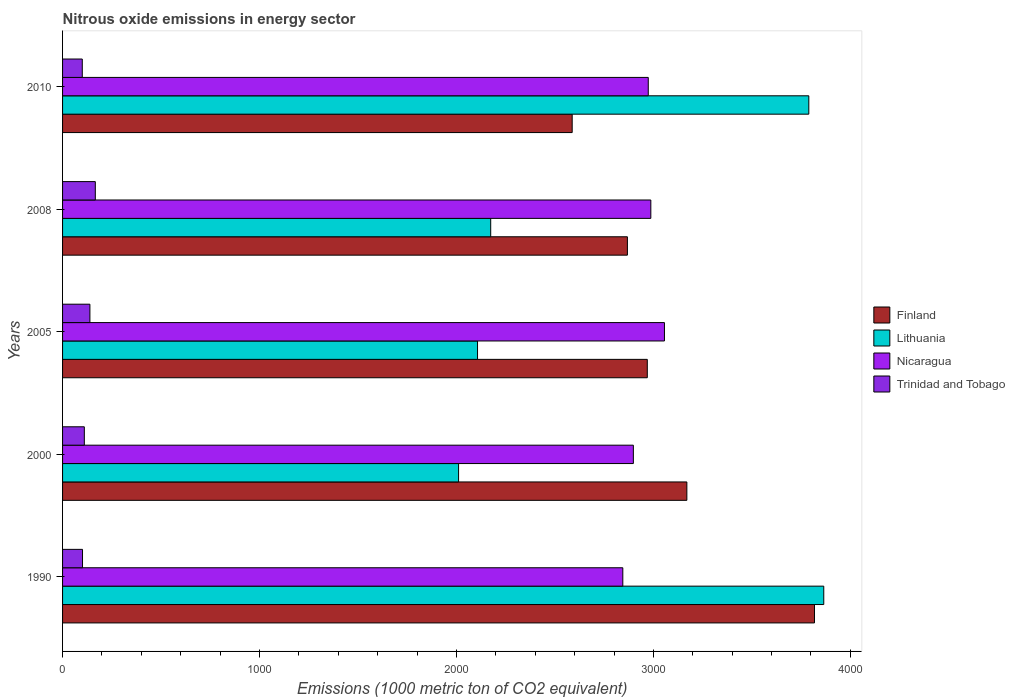Are the number of bars on each tick of the Y-axis equal?
Provide a short and direct response. Yes. How many bars are there on the 2nd tick from the top?
Ensure brevity in your answer.  4. What is the amount of nitrous oxide emitted in Lithuania in 2010?
Ensure brevity in your answer.  3789.1. Across all years, what is the maximum amount of nitrous oxide emitted in Lithuania?
Make the answer very short. 3865. Across all years, what is the minimum amount of nitrous oxide emitted in Lithuania?
Offer a terse response. 2010.8. In which year was the amount of nitrous oxide emitted in Nicaragua maximum?
Provide a short and direct response. 2005. What is the total amount of nitrous oxide emitted in Finland in the graph?
Give a very brief answer. 1.54e+04. What is the difference between the amount of nitrous oxide emitted in Lithuania in 2000 and that in 2005?
Provide a succinct answer. -96.2. What is the difference between the amount of nitrous oxide emitted in Trinidad and Tobago in 2010 and the amount of nitrous oxide emitted in Finland in 2008?
Make the answer very short. -2767.9. What is the average amount of nitrous oxide emitted in Finland per year?
Ensure brevity in your answer.  3082.48. In the year 2005, what is the difference between the amount of nitrous oxide emitted in Lithuania and amount of nitrous oxide emitted in Nicaragua?
Make the answer very short. -949.1. In how many years, is the amount of nitrous oxide emitted in Lithuania greater than 1200 1000 metric ton?
Ensure brevity in your answer.  5. What is the ratio of the amount of nitrous oxide emitted in Nicaragua in 2000 to that in 2005?
Offer a very short reply. 0.95. Is the amount of nitrous oxide emitted in Finland in 2000 less than that in 2010?
Give a very brief answer. No. Is the difference between the amount of nitrous oxide emitted in Lithuania in 1990 and 2010 greater than the difference between the amount of nitrous oxide emitted in Nicaragua in 1990 and 2010?
Your answer should be compact. Yes. What is the difference between the highest and the second highest amount of nitrous oxide emitted in Trinidad and Tobago?
Your answer should be very brief. 27.5. What is the difference between the highest and the lowest amount of nitrous oxide emitted in Lithuania?
Your answer should be compact. 1854.2. In how many years, is the amount of nitrous oxide emitted in Nicaragua greater than the average amount of nitrous oxide emitted in Nicaragua taken over all years?
Give a very brief answer. 3. What does the 2nd bar from the top in 2010 represents?
Offer a very short reply. Nicaragua. What does the 3rd bar from the bottom in 2005 represents?
Keep it short and to the point. Nicaragua. Is it the case that in every year, the sum of the amount of nitrous oxide emitted in Lithuania and amount of nitrous oxide emitted in Nicaragua is greater than the amount of nitrous oxide emitted in Finland?
Give a very brief answer. Yes. How many bars are there?
Ensure brevity in your answer.  20. How many years are there in the graph?
Keep it short and to the point. 5. Are the values on the major ticks of X-axis written in scientific E-notation?
Ensure brevity in your answer.  No. Does the graph contain any zero values?
Your answer should be very brief. No. Does the graph contain grids?
Your answer should be compact. No. How many legend labels are there?
Provide a succinct answer. 4. How are the legend labels stacked?
Ensure brevity in your answer.  Vertical. What is the title of the graph?
Ensure brevity in your answer.  Nitrous oxide emissions in energy sector. What is the label or title of the X-axis?
Provide a succinct answer. Emissions (1000 metric ton of CO2 equivalent). What is the Emissions (1000 metric ton of CO2 equivalent) of Finland in 1990?
Your answer should be very brief. 3817.9. What is the Emissions (1000 metric ton of CO2 equivalent) in Lithuania in 1990?
Offer a very short reply. 3865. What is the Emissions (1000 metric ton of CO2 equivalent) of Nicaragua in 1990?
Ensure brevity in your answer.  2844.7. What is the Emissions (1000 metric ton of CO2 equivalent) in Trinidad and Tobago in 1990?
Offer a very short reply. 101.3. What is the Emissions (1000 metric ton of CO2 equivalent) in Finland in 2000?
Ensure brevity in your answer.  3169.9. What is the Emissions (1000 metric ton of CO2 equivalent) of Lithuania in 2000?
Your response must be concise. 2010.8. What is the Emissions (1000 metric ton of CO2 equivalent) in Nicaragua in 2000?
Your answer should be compact. 2898.2. What is the Emissions (1000 metric ton of CO2 equivalent) in Trinidad and Tobago in 2000?
Give a very brief answer. 110.5. What is the Emissions (1000 metric ton of CO2 equivalent) in Finland in 2005?
Your answer should be very brief. 2969. What is the Emissions (1000 metric ton of CO2 equivalent) of Lithuania in 2005?
Offer a very short reply. 2107. What is the Emissions (1000 metric ton of CO2 equivalent) in Nicaragua in 2005?
Give a very brief answer. 3056.1. What is the Emissions (1000 metric ton of CO2 equivalent) in Trinidad and Tobago in 2005?
Your answer should be compact. 138.8. What is the Emissions (1000 metric ton of CO2 equivalent) of Finland in 2008?
Make the answer very short. 2868. What is the Emissions (1000 metric ton of CO2 equivalent) of Lithuania in 2008?
Your answer should be compact. 2173.9. What is the Emissions (1000 metric ton of CO2 equivalent) of Nicaragua in 2008?
Ensure brevity in your answer.  2986.9. What is the Emissions (1000 metric ton of CO2 equivalent) of Trinidad and Tobago in 2008?
Offer a very short reply. 166.3. What is the Emissions (1000 metric ton of CO2 equivalent) in Finland in 2010?
Give a very brief answer. 2587.6. What is the Emissions (1000 metric ton of CO2 equivalent) in Lithuania in 2010?
Provide a short and direct response. 3789.1. What is the Emissions (1000 metric ton of CO2 equivalent) of Nicaragua in 2010?
Make the answer very short. 2973.9. What is the Emissions (1000 metric ton of CO2 equivalent) of Trinidad and Tobago in 2010?
Your answer should be compact. 100.1. Across all years, what is the maximum Emissions (1000 metric ton of CO2 equivalent) of Finland?
Provide a short and direct response. 3817.9. Across all years, what is the maximum Emissions (1000 metric ton of CO2 equivalent) in Lithuania?
Keep it short and to the point. 3865. Across all years, what is the maximum Emissions (1000 metric ton of CO2 equivalent) of Nicaragua?
Make the answer very short. 3056.1. Across all years, what is the maximum Emissions (1000 metric ton of CO2 equivalent) of Trinidad and Tobago?
Your response must be concise. 166.3. Across all years, what is the minimum Emissions (1000 metric ton of CO2 equivalent) in Finland?
Keep it short and to the point. 2587.6. Across all years, what is the minimum Emissions (1000 metric ton of CO2 equivalent) of Lithuania?
Give a very brief answer. 2010.8. Across all years, what is the minimum Emissions (1000 metric ton of CO2 equivalent) of Nicaragua?
Your answer should be very brief. 2844.7. Across all years, what is the minimum Emissions (1000 metric ton of CO2 equivalent) in Trinidad and Tobago?
Provide a short and direct response. 100.1. What is the total Emissions (1000 metric ton of CO2 equivalent) in Finland in the graph?
Your response must be concise. 1.54e+04. What is the total Emissions (1000 metric ton of CO2 equivalent) of Lithuania in the graph?
Ensure brevity in your answer.  1.39e+04. What is the total Emissions (1000 metric ton of CO2 equivalent) of Nicaragua in the graph?
Keep it short and to the point. 1.48e+04. What is the total Emissions (1000 metric ton of CO2 equivalent) of Trinidad and Tobago in the graph?
Ensure brevity in your answer.  617. What is the difference between the Emissions (1000 metric ton of CO2 equivalent) of Finland in 1990 and that in 2000?
Offer a very short reply. 648. What is the difference between the Emissions (1000 metric ton of CO2 equivalent) in Lithuania in 1990 and that in 2000?
Your answer should be compact. 1854.2. What is the difference between the Emissions (1000 metric ton of CO2 equivalent) of Nicaragua in 1990 and that in 2000?
Your response must be concise. -53.5. What is the difference between the Emissions (1000 metric ton of CO2 equivalent) of Finland in 1990 and that in 2005?
Keep it short and to the point. 848.9. What is the difference between the Emissions (1000 metric ton of CO2 equivalent) of Lithuania in 1990 and that in 2005?
Ensure brevity in your answer.  1758. What is the difference between the Emissions (1000 metric ton of CO2 equivalent) of Nicaragua in 1990 and that in 2005?
Make the answer very short. -211.4. What is the difference between the Emissions (1000 metric ton of CO2 equivalent) of Trinidad and Tobago in 1990 and that in 2005?
Keep it short and to the point. -37.5. What is the difference between the Emissions (1000 metric ton of CO2 equivalent) of Finland in 1990 and that in 2008?
Provide a succinct answer. 949.9. What is the difference between the Emissions (1000 metric ton of CO2 equivalent) in Lithuania in 1990 and that in 2008?
Ensure brevity in your answer.  1691.1. What is the difference between the Emissions (1000 metric ton of CO2 equivalent) in Nicaragua in 1990 and that in 2008?
Give a very brief answer. -142.2. What is the difference between the Emissions (1000 metric ton of CO2 equivalent) of Trinidad and Tobago in 1990 and that in 2008?
Make the answer very short. -65. What is the difference between the Emissions (1000 metric ton of CO2 equivalent) of Finland in 1990 and that in 2010?
Give a very brief answer. 1230.3. What is the difference between the Emissions (1000 metric ton of CO2 equivalent) of Lithuania in 1990 and that in 2010?
Your answer should be very brief. 75.9. What is the difference between the Emissions (1000 metric ton of CO2 equivalent) in Nicaragua in 1990 and that in 2010?
Offer a terse response. -129.2. What is the difference between the Emissions (1000 metric ton of CO2 equivalent) of Trinidad and Tobago in 1990 and that in 2010?
Keep it short and to the point. 1.2. What is the difference between the Emissions (1000 metric ton of CO2 equivalent) of Finland in 2000 and that in 2005?
Offer a terse response. 200.9. What is the difference between the Emissions (1000 metric ton of CO2 equivalent) of Lithuania in 2000 and that in 2005?
Keep it short and to the point. -96.2. What is the difference between the Emissions (1000 metric ton of CO2 equivalent) in Nicaragua in 2000 and that in 2005?
Offer a very short reply. -157.9. What is the difference between the Emissions (1000 metric ton of CO2 equivalent) in Trinidad and Tobago in 2000 and that in 2005?
Provide a short and direct response. -28.3. What is the difference between the Emissions (1000 metric ton of CO2 equivalent) of Finland in 2000 and that in 2008?
Your response must be concise. 301.9. What is the difference between the Emissions (1000 metric ton of CO2 equivalent) in Lithuania in 2000 and that in 2008?
Your response must be concise. -163.1. What is the difference between the Emissions (1000 metric ton of CO2 equivalent) of Nicaragua in 2000 and that in 2008?
Your answer should be compact. -88.7. What is the difference between the Emissions (1000 metric ton of CO2 equivalent) in Trinidad and Tobago in 2000 and that in 2008?
Offer a terse response. -55.8. What is the difference between the Emissions (1000 metric ton of CO2 equivalent) in Finland in 2000 and that in 2010?
Provide a succinct answer. 582.3. What is the difference between the Emissions (1000 metric ton of CO2 equivalent) of Lithuania in 2000 and that in 2010?
Provide a succinct answer. -1778.3. What is the difference between the Emissions (1000 metric ton of CO2 equivalent) of Nicaragua in 2000 and that in 2010?
Offer a terse response. -75.7. What is the difference between the Emissions (1000 metric ton of CO2 equivalent) in Trinidad and Tobago in 2000 and that in 2010?
Provide a short and direct response. 10.4. What is the difference between the Emissions (1000 metric ton of CO2 equivalent) of Finland in 2005 and that in 2008?
Offer a terse response. 101. What is the difference between the Emissions (1000 metric ton of CO2 equivalent) in Lithuania in 2005 and that in 2008?
Your response must be concise. -66.9. What is the difference between the Emissions (1000 metric ton of CO2 equivalent) in Nicaragua in 2005 and that in 2008?
Give a very brief answer. 69.2. What is the difference between the Emissions (1000 metric ton of CO2 equivalent) in Trinidad and Tobago in 2005 and that in 2008?
Provide a succinct answer. -27.5. What is the difference between the Emissions (1000 metric ton of CO2 equivalent) of Finland in 2005 and that in 2010?
Your response must be concise. 381.4. What is the difference between the Emissions (1000 metric ton of CO2 equivalent) in Lithuania in 2005 and that in 2010?
Your answer should be very brief. -1682.1. What is the difference between the Emissions (1000 metric ton of CO2 equivalent) in Nicaragua in 2005 and that in 2010?
Your answer should be compact. 82.2. What is the difference between the Emissions (1000 metric ton of CO2 equivalent) in Trinidad and Tobago in 2005 and that in 2010?
Your response must be concise. 38.7. What is the difference between the Emissions (1000 metric ton of CO2 equivalent) of Finland in 2008 and that in 2010?
Make the answer very short. 280.4. What is the difference between the Emissions (1000 metric ton of CO2 equivalent) of Lithuania in 2008 and that in 2010?
Your response must be concise. -1615.2. What is the difference between the Emissions (1000 metric ton of CO2 equivalent) in Nicaragua in 2008 and that in 2010?
Your answer should be compact. 13. What is the difference between the Emissions (1000 metric ton of CO2 equivalent) in Trinidad and Tobago in 2008 and that in 2010?
Your answer should be compact. 66.2. What is the difference between the Emissions (1000 metric ton of CO2 equivalent) of Finland in 1990 and the Emissions (1000 metric ton of CO2 equivalent) of Lithuania in 2000?
Your answer should be compact. 1807.1. What is the difference between the Emissions (1000 metric ton of CO2 equivalent) of Finland in 1990 and the Emissions (1000 metric ton of CO2 equivalent) of Nicaragua in 2000?
Keep it short and to the point. 919.7. What is the difference between the Emissions (1000 metric ton of CO2 equivalent) in Finland in 1990 and the Emissions (1000 metric ton of CO2 equivalent) in Trinidad and Tobago in 2000?
Your response must be concise. 3707.4. What is the difference between the Emissions (1000 metric ton of CO2 equivalent) of Lithuania in 1990 and the Emissions (1000 metric ton of CO2 equivalent) of Nicaragua in 2000?
Make the answer very short. 966.8. What is the difference between the Emissions (1000 metric ton of CO2 equivalent) in Lithuania in 1990 and the Emissions (1000 metric ton of CO2 equivalent) in Trinidad and Tobago in 2000?
Provide a short and direct response. 3754.5. What is the difference between the Emissions (1000 metric ton of CO2 equivalent) in Nicaragua in 1990 and the Emissions (1000 metric ton of CO2 equivalent) in Trinidad and Tobago in 2000?
Ensure brevity in your answer.  2734.2. What is the difference between the Emissions (1000 metric ton of CO2 equivalent) in Finland in 1990 and the Emissions (1000 metric ton of CO2 equivalent) in Lithuania in 2005?
Your answer should be very brief. 1710.9. What is the difference between the Emissions (1000 metric ton of CO2 equivalent) in Finland in 1990 and the Emissions (1000 metric ton of CO2 equivalent) in Nicaragua in 2005?
Give a very brief answer. 761.8. What is the difference between the Emissions (1000 metric ton of CO2 equivalent) of Finland in 1990 and the Emissions (1000 metric ton of CO2 equivalent) of Trinidad and Tobago in 2005?
Ensure brevity in your answer.  3679.1. What is the difference between the Emissions (1000 metric ton of CO2 equivalent) of Lithuania in 1990 and the Emissions (1000 metric ton of CO2 equivalent) of Nicaragua in 2005?
Offer a terse response. 808.9. What is the difference between the Emissions (1000 metric ton of CO2 equivalent) in Lithuania in 1990 and the Emissions (1000 metric ton of CO2 equivalent) in Trinidad and Tobago in 2005?
Give a very brief answer. 3726.2. What is the difference between the Emissions (1000 metric ton of CO2 equivalent) in Nicaragua in 1990 and the Emissions (1000 metric ton of CO2 equivalent) in Trinidad and Tobago in 2005?
Give a very brief answer. 2705.9. What is the difference between the Emissions (1000 metric ton of CO2 equivalent) in Finland in 1990 and the Emissions (1000 metric ton of CO2 equivalent) in Lithuania in 2008?
Offer a very short reply. 1644. What is the difference between the Emissions (1000 metric ton of CO2 equivalent) in Finland in 1990 and the Emissions (1000 metric ton of CO2 equivalent) in Nicaragua in 2008?
Offer a terse response. 831. What is the difference between the Emissions (1000 metric ton of CO2 equivalent) of Finland in 1990 and the Emissions (1000 metric ton of CO2 equivalent) of Trinidad and Tobago in 2008?
Offer a very short reply. 3651.6. What is the difference between the Emissions (1000 metric ton of CO2 equivalent) in Lithuania in 1990 and the Emissions (1000 metric ton of CO2 equivalent) in Nicaragua in 2008?
Offer a terse response. 878.1. What is the difference between the Emissions (1000 metric ton of CO2 equivalent) of Lithuania in 1990 and the Emissions (1000 metric ton of CO2 equivalent) of Trinidad and Tobago in 2008?
Give a very brief answer. 3698.7. What is the difference between the Emissions (1000 metric ton of CO2 equivalent) in Nicaragua in 1990 and the Emissions (1000 metric ton of CO2 equivalent) in Trinidad and Tobago in 2008?
Make the answer very short. 2678.4. What is the difference between the Emissions (1000 metric ton of CO2 equivalent) of Finland in 1990 and the Emissions (1000 metric ton of CO2 equivalent) of Lithuania in 2010?
Your response must be concise. 28.8. What is the difference between the Emissions (1000 metric ton of CO2 equivalent) of Finland in 1990 and the Emissions (1000 metric ton of CO2 equivalent) of Nicaragua in 2010?
Ensure brevity in your answer.  844. What is the difference between the Emissions (1000 metric ton of CO2 equivalent) in Finland in 1990 and the Emissions (1000 metric ton of CO2 equivalent) in Trinidad and Tobago in 2010?
Your response must be concise. 3717.8. What is the difference between the Emissions (1000 metric ton of CO2 equivalent) of Lithuania in 1990 and the Emissions (1000 metric ton of CO2 equivalent) of Nicaragua in 2010?
Make the answer very short. 891.1. What is the difference between the Emissions (1000 metric ton of CO2 equivalent) of Lithuania in 1990 and the Emissions (1000 metric ton of CO2 equivalent) of Trinidad and Tobago in 2010?
Your answer should be very brief. 3764.9. What is the difference between the Emissions (1000 metric ton of CO2 equivalent) of Nicaragua in 1990 and the Emissions (1000 metric ton of CO2 equivalent) of Trinidad and Tobago in 2010?
Make the answer very short. 2744.6. What is the difference between the Emissions (1000 metric ton of CO2 equivalent) in Finland in 2000 and the Emissions (1000 metric ton of CO2 equivalent) in Lithuania in 2005?
Provide a short and direct response. 1062.9. What is the difference between the Emissions (1000 metric ton of CO2 equivalent) of Finland in 2000 and the Emissions (1000 metric ton of CO2 equivalent) of Nicaragua in 2005?
Ensure brevity in your answer.  113.8. What is the difference between the Emissions (1000 metric ton of CO2 equivalent) of Finland in 2000 and the Emissions (1000 metric ton of CO2 equivalent) of Trinidad and Tobago in 2005?
Ensure brevity in your answer.  3031.1. What is the difference between the Emissions (1000 metric ton of CO2 equivalent) in Lithuania in 2000 and the Emissions (1000 metric ton of CO2 equivalent) in Nicaragua in 2005?
Provide a succinct answer. -1045.3. What is the difference between the Emissions (1000 metric ton of CO2 equivalent) of Lithuania in 2000 and the Emissions (1000 metric ton of CO2 equivalent) of Trinidad and Tobago in 2005?
Your answer should be compact. 1872. What is the difference between the Emissions (1000 metric ton of CO2 equivalent) in Nicaragua in 2000 and the Emissions (1000 metric ton of CO2 equivalent) in Trinidad and Tobago in 2005?
Keep it short and to the point. 2759.4. What is the difference between the Emissions (1000 metric ton of CO2 equivalent) in Finland in 2000 and the Emissions (1000 metric ton of CO2 equivalent) in Lithuania in 2008?
Make the answer very short. 996. What is the difference between the Emissions (1000 metric ton of CO2 equivalent) in Finland in 2000 and the Emissions (1000 metric ton of CO2 equivalent) in Nicaragua in 2008?
Offer a very short reply. 183. What is the difference between the Emissions (1000 metric ton of CO2 equivalent) of Finland in 2000 and the Emissions (1000 metric ton of CO2 equivalent) of Trinidad and Tobago in 2008?
Offer a terse response. 3003.6. What is the difference between the Emissions (1000 metric ton of CO2 equivalent) of Lithuania in 2000 and the Emissions (1000 metric ton of CO2 equivalent) of Nicaragua in 2008?
Your answer should be compact. -976.1. What is the difference between the Emissions (1000 metric ton of CO2 equivalent) in Lithuania in 2000 and the Emissions (1000 metric ton of CO2 equivalent) in Trinidad and Tobago in 2008?
Give a very brief answer. 1844.5. What is the difference between the Emissions (1000 metric ton of CO2 equivalent) in Nicaragua in 2000 and the Emissions (1000 metric ton of CO2 equivalent) in Trinidad and Tobago in 2008?
Make the answer very short. 2731.9. What is the difference between the Emissions (1000 metric ton of CO2 equivalent) of Finland in 2000 and the Emissions (1000 metric ton of CO2 equivalent) of Lithuania in 2010?
Provide a succinct answer. -619.2. What is the difference between the Emissions (1000 metric ton of CO2 equivalent) of Finland in 2000 and the Emissions (1000 metric ton of CO2 equivalent) of Nicaragua in 2010?
Offer a very short reply. 196. What is the difference between the Emissions (1000 metric ton of CO2 equivalent) of Finland in 2000 and the Emissions (1000 metric ton of CO2 equivalent) of Trinidad and Tobago in 2010?
Provide a short and direct response. 3069.8. What is the difference between the Emissions (1000 metric ton of CO2 equivalent) of Lithuania in 2000 and the Emissions (1000 metric ton of CO2 equivalent) of Nicaragua in 2010?
Provide a succinct answer. -963.1. What is the difference between the Emissions (1000 metric ton of CO2 equivalent) of Lithuania in 2000 and the Emissions (1000 metric ton of CO2 equivalent) of Trinidad and Tobago in 2010?
Provide a short and direct response. 1910.7. What is the difference between the Emissions (1000 metric ton of CO2 equivalent) of Nicaragua in 2000 and the Emissions (1000 metric ton of CO2 equivalent) of Trinidad and Tobago in 2010?
Ensure brevity in your answer.  2798.1. What is the difference between the Emissions (1000 metric ton of CO2 equivalent) of Finland in 2005 and the Emissions (1000 metric ton of CO2 equivalent) of Lithuania in 2008?
Your answer should be compact. 795.1. What is the difference between the Emissions (1000 metric ton of CO2 equivalent) in Finland in 2005 and the Emissions (1000 metric ton of CO2 equivalent) in Nicaragua in 2008?
Provide a short and direct response. -17.9. What is the difference between the Emissions (1000 metric ton of CO2 equivalent) in Finland in 2005 and the Emissions (1000 metric ton of CO2 equivalent) in Trinidad and Tobago in 2008?
Provide a succinct answer. 2802.7. What is the difference between the Emissions (1000 metric ton of CO2 equivalent) in Lithuania in 2005 and the Emissions (1000 metric ton of CO2 equivalent) in Nicaragua in 2008?
Offer a terse response. -879.9. What is the difference between the Emissions (1000 metric ton of CO2 equivalent) in Lithuania in 2005 and the Emissions (1000 metric ton of CO2 equivalent) in Trinidad and Tobago in 2008?
Make the answer very short. 1940.7. What is the difference between the Emissions (1000 metric ton of CO2 equivalent) in Nicaragua in 2005 and the Emissions (1000 metric ton of CO2 equivalent) in Trinidad and Tobago in 2008?
Ensure brevity in your answer.  2889.8. What is the difference between the Emissions (1000 metric ton of CO2 equivalent) in Finland in 2005 and the Emissions (1000 metric ton of CO2 equivalent) in Lithuania in 2010?
Give a very brief answer. -820.1. What is the difference between the Emissions (1000 metric ton of CO2 equivalent) in Finland in 2005 and the Emissions (1000 metric ton of CO2 equivalent) in Trinidad and Tobago in 2010?
Give a very brief answer. 2868.9. What is the difference between the Emissions (1000 metric ton of CO2 equivalent) of Lithuania in 2005 and the Emissions (1000 metric ton of CO2 equivalent) of Nicaragua in 2010?
Your answer should be compact. -866.9. What is the difference between the Emissions (1000 metric ton of CO2 equivalent) of Lithuania in 2005 and the Emissions (1000 metric ton of CO2 equivalent) of Trinidad and Tobago in 2010?
Your response must be concise. 2006.9. What is the difference between the Emissions (1000 metric ton of CO2 equivalent) in Nicaragua in 2005 and the Emissions (1000 metric ton of CO2 equivalent) in Trinidad and Tobago in 2010?
Offer a terse response. 2956. What is the difference between the Emissions (1000 metric ton of CO2 equivalent) of Finland in 2008 and the Emissions (1000 metric ton of CO2 equivalent) of Lithuania in 2010?
Offer a very short reply. -921.1. What is the difference between the Emissions (1000 metric ton of CO2 equivalent) in Finland in 2008 and the Emissions (1000 metric ton of CO2 equivalent) in Nicaragua in 2010?
Offer a very short reply. -105.9. What is the difference between the Emissions (1000 metric ton of CO2 equivalent) of Finland in 2008 and the Emissions (1000 metric ton of CO2 equivalent) of Trinidad and Tobago in 2010?
Make the answer very short. 2767.9. What is the difference between the Emissions (1000 metric ton of CO2 equivalent) of Lithuania in 2008 and the Emissions (1000 metric ton of CO2 equivalent) of Nicaragua in 2010?
Your answer should be very brief. -800. What is the difference between the Emissions (1000 metric ton of CO2 equivalent) in Lithuania in 2008 and the Emissions (1000 metric ton of CO2 equivalent) in Trinidad and Tobago in 2010?
Give a very brief answer. 2073.8. What is the difference between the Emissions (1000 metric ton of CO2 equivalent) of Nicaragua in 2008 and the Emissions (1000 metric ton of CO2 equivalent) of Trinidad and Tobago in 2010?
Your answer should be compact. 2886.8. What is the average Emissions (1000 metric ton of CO2 equivalent) of Finland per year?
Your answer should be compact. 3082.48. What is the average Emissions (1000 metric ton of CO2 equivalent) of Lithuania per year?
Your answer should be very brief. 2789.16. What is the average Emissions (1000 metric ton of CO2 equivalent) in Nicaragua per year?
Give a very brief answer. 2951.96. What is the average Emissions (1000 metric ton of CO2 equivalent) in Trinidad and Tobago per year?
Your answer should be very brief. 123.4. In the year 1990, what is the difference between the Emissions (1000 metric ton of CO2 equivalent) of Finland and Emissions (1000 metric ton of CO2 equivalent) of Lithuania?
Provide a short and direct response. -47.1. In the year 1990, what is the difference between the Emissions (1000 metric ton of CO2 equivalent) of Finland and Emissions (1000 metric ton of CO2 equivalent) of Nicaragua?
Your response must be concise. 973.2. In the year 1990, what is the difference between the Emissions (1000 metric ton of CO2 equivalent) of Finland and Emissions (1000 metric ton of CO2 equivalent) of Trinidad and Tobago?
Give a very brief answer. 3716.6. In the year 1990, what is the difference between the Emissions (1000 metric ton of CO2 equivalent) of Lithuania and Emissions (1000 metric ton of CO2 equivalent) of Nicaragua?
Provide a short and direct response. 1020.3. In the year 1990, what is the difference between the Emissions (1000 metric ton of CO2 equivalent) in Lithuania and Emissions (1000 metric ton of CO2 equivalent) in Trinidad and Tobago?
Make the answer very short. 3763.7. In the year 1990, what is the difference between the Emissions (1000 metric ton of CO2 equivalent) of Nicaragua and Emissions (1000 metric ton of CO2 equivalent) of Trinidad and Tobago?
Provide a short and direct response. 2743.4. In the year 2000, what is the difference between the Emissions (1000 metric ton of CO2 equivalent) of Finland and Emissions (1000 metric ton of CO2 equivalent) of Lithuania?
Your response must be concise. 1159.1. In the year 2000, what is the difference between the Emissions (1000 metric ton of CO2 equivalent) in Finland and Emissions (1000 metric ton of CO2 equivalent) in Nicaragua?
Offer a terse response. 271.7. In the year 2000, what is the difference between the Emissions (1000 metric ton of CO2 equivalent) of Finland and Emissions (1000 metric ton of CO2 equivalent) of Trinidad and Tobago?
Offer a terse response. 3059.4. In the year 2000, what is the difference between the Emissions (1000 metric ton of CO2 equivalent) of Lithuania and Emissions (1000 metric ton of CO2 equivalent) of Nicaragua?
Your response must be concise. -887.4. In the year 2000, what is the difference between the Emissions (1000 metric ton of CO2 equivalent) in Lithuania and Emissions (1000 metric ton of CO2 equivalent) in Trinidad and Tobago?
Offer a very short reply. 1900.3. In the year 2000, what is the difference between the Emissions (1000 metric ton of CO2 equivalent) of Nicaragua and Emissions (1000 metric ton of CO2 equivalent) of Trinidad and Tobago?
Keep it short and to the point. 2787.7. In the year 2005, what is the difference between the Emissions (1000 metric ton of CO2 equivalent) in Finland and Emissions (1000 metric ton of CO2 equivalent) in Lithuania?
Give a very brief answer. 862. In the year 2005, what is the difference between the Emissions (1000 metric ton of CO2 equivalent) in Finland and Emissions (1000 metric ton of CO2 equivalent) in Nicaragua?
Provide a short and direct response. -87.1. In the year 2005, what is the difference between the Emissions (1000 metric ton of CO2 equivalent) in Finland and Emissions (1000 metric ton of CO2 equivalent) in Trinidad and Tobago?
Offer a terse response. 2830.2. In the year 2005, what is the difference between the Emissions (1000 metric ton of CO2 equivalent) of Lithuania and Emissions (1000 metric ton of CO2 equivalent) of Nicaragua?
Your answer should be very brief. -949.1. In the year 2005, what is the difference between the Emissions (1000 metric ton of CO2 equivalent) of Lithuania and Emissions (1000 metric ton of CO2 equivalent) of Trinidad and Tobago?
Keep it short and to the point. 1968.2. In the year 2005, what is the difference between the Emissions (1000 metric ton of CO2 equivalent) in Nicaragua and Emissions (1000 metric ton of CO2 equivalent) in Trinidad and Tobago?
Offer a terse response. 2917.3. In the year 2008, what is the difference between the Emissions (1000 metric ton of CO2 equivalent) in Finland and Emissions (1000 metric ton of CO2 equivalent) in Lithuania?
Your answer should be very brief. 694.1. In the year 2008, what is the difference between the Emissions (1000 metric ton of CO2 equivalent) of Finland and Emissions (1000 metric ton of CO2 equivalent) of Nicaragua?
Your answer should be very brief. -118.9. In the year 2008, what is the difference between the Emissions (1000 metric ton of CO2 equivalent) in Finland and Emissions (1000 metric ton of CO2 equivalent) in Trinidad and Tobago?
Offer a very short reply. 2701.7. In the year 2008, what is the difference between the Emissions (1000 metric ton of CO2 equivalent) of Lithuania and Emissions (1000 metric ton of CO2 equivalent) of Nicaragua?
Keep it short and to the point. -813. In the year 2008, what is the difference between the Emissions (1000 metric ton of CO2 equivalent) in Lithuania and Emissions (1000 metric ton of CO2 equivalent) in Trinidad and Tobago?
Provide a succinct answer. 2007.6. In the year 2008, what is the difference between the Emissions (1000 metric ton of CO2 equivalent) in Nicaragua and Emissions (1000 metric ton of CO2 equivalent) in Trinidad and Tobago?
Offer a terse response. 2820.6. In the year 2010, what is the difference between the Emissions (1000 metric ton of CO2 equivalent) of Finland and Emissions (1000 metric ton of CO2 equivalent) of Lithuania?
Offer a terse response. -1201.5. In the year 2010, what is the difference between the Emissions (1000 metric ton of CO2 equivalent) in Finland and Emissions (1000 metric ton of CO2 equivalent) in Nicaragua?
Your response must be concise. -386.3. In the year 2010, what is the difference between the Emissions (1000 metric ton of CO2 equivalent) of Finland and Emissions (1000 metric ton of CO2 equivalent) of Trinidad and Tobago?
Provide a succinct answer. 2487.5. In the year 2010, what is the difference between the Emissions (1000 metric ton of CO2 equivalent) of Lithuania and Emissions (1000 metric ton of CO2 equivalent) of Nicaragua?
Your answer should be compact. 815.2. In the year 2010, what is the difference between the Emissions (1000 metric ton of CO2 equivalent) of Lithuania and Emissions (1000 metric ton of CO2 equivalent) of Trinidad and Tobago?
Your answer should be compact. 3689. In the year 2010, what is the difference between the Emissions (1000 metric ton of CO2 equivalent) of Nicaragua and Emissions (1000 metric ton of CO2 equivalent) of Trinidad and Tobago?
Your response must be concise. 2873.8. What is the ratio of the Emissions (1000 metric ton of CO2 equivalent) of Finland in 1990 to that in 2000?
Offer a terse response. 1.2. What is the ratio of the Emissions (1000 metric ton of CO2 equivalent) of Lithuania in 1990 to that in 2000?
Offer a terse response. 1.92. What is the ratio of the Emissions (1000 metric ton of CO2 equivalent) in Nicaragua in 1990 to that in 2000?
Give a very brief answer. 0.98. What is the ratio of the Emissions (1000 metric ton of CO2 equivalent) in Trinidad and Tobago in 1990 to that in 2000?
Offer a very short reply. 0.92. What is the ratio of the Emissions (1000 metric ton of CO2 equivalent) of Finland in 1990 to that in 2005?
Your response must be concise. 1.29. What is the ratio of the Emissions (1000 metric ton of CO2 equivalent) of Lithuania in 1990 to that in 2005?
Provide a succinct answer. 1.83. What is the ratio of the Emissions (1000 metric ton of CO2 equivalent) in Nicaragua in 1990 to that in 2005?
Provide a succinct answer. 0.93. What is the ratio of the Emissions (1000 metric ton of CO2 equivalent) of Trinidad and Tobago in 1990 to that in 2005?
Keep it short and to the point. 0.73. What is the ratio of the Emissions (1000 metric ton of CO2 equivalent) in Finland in 1990 to that in 2008?
Ensure brevity in your answer.  1.33. What is the ratio of the Emissions (1000 metric ton of CO2 equivalent) of Lithuania in 1990 to that in 2008?
Give a very brief answer. 1.78. What is the ratio of the Emissions (1000 metric ton of CO2 equivalent) of Nicaragua in 1990 to that in 2008?
Keep it short and to the point. 0.95. What is the ratio of the Emissions (1000 metric ton of CO2 equivalent) of Trinidad and Tobago in 1990 to that in 2008?
Provide a succinct answer. 0.61. What is the ratio of the Emissions (1000 metric ton of CO2 equivalent) in Finland in 1990 to that in 2010?
Give a very brief answer. 1.48. What is the ratio of the Emissions (1000 metric ton of CO2 equivalent) of Nicaragua in 1990 to that in 2010?
Ensure brevity in your answer.  0.96. What is the ratio of the Emissions (1000 metric ton of CO2 equivalent) of Finland in 2000 to that in 2005?
Offer a very short reply. 1.07. What is the ratio of the Emissions (1000 metric ton of CO2 equivalent) of Lithuania in 2000 to that in 2005?
Offer a very short reply. 0.95. What is the ratio of the Emissions (1000 metric ton of CO2 equivalent) in Nicaragua in 2000 to that in 2005?
Offer a very short reply. 0.95. What is the ratio of the Emissions (1000 metric ton of CO2 equivalent) in Trinidad and Tobago in 2000 to that in 2005?
Offer a very short reply. 0.8. What is the ratio of the Emissions (1000 metric ton of CO2 equivalent) of Finland in 2000 to that in 2008?
Your answer should be compact. 1.11. What is the ratio of the Emissions (1000 metric ton of CO2 equivalent) in Lithuania in 2000 to that in 2008?
Offer a terse response. 0.93. What is the ratio of the Emissions (1000 metric ton of CO2 equivalent) in Nicaragua in 2000 to that in 2008?
Your answer should be very brief. 0.97. What is the ratio of the Emissions (1000 metric ton of CO2 equivalent) in Trinidad and Tobago in 2000 to that in 2008?
Offer a terse response. 0.66. What is the ratio of the Emissions (1000 metric ton of CO2 equivalent) of Finland in 2000 to that in 2010?
Provide a succinct answer. 1.23. What is the ratio of the Emissions (1000 metric ton of CO2 equivalent) of Lithuania in 2000 to that in 2010?
Your response must be concise. 0.53. What is the ratio of the Emissions (1000 metric ton of CO2 equivalent) of Nicaragua in 2000 to that in 2010?
Keep it short and to the point. 0.97. What is the ratio of the Emissions (1000 metric ton of CO2 equivalent) in Trinidad and Tobago in 2000 to that in 2010?
Your response must be concise. 1.1. What is the ratio of the Emissions (1000 metric ton of CO2 equivalent) of Finland in 2005 to that in 2008?
Offer a terse response. 1.04. What is the ratio of the Emissions (1000 metric ton of CO2 equivalent) in Lithuania in 2005 to that in 2008?
Your answer should be very brief. 0.97. What is the ratio of the Emissions (1000 metric ton of CO2 equivalent) of Nicaragua in 2005 to that in 2008?
Keep it short and to the point. 1.02. What is the ratio of the Emissions (1000 metric ton of CO2 equivalent) of Trinidad and Tobago in 2005 to that in 2008?
Keep it short and to the point. 0.83. What is the ratio of the Emissions (1000 metric ton of CO2 equivalent) in Finland in 2005 to that in 2010?
Give a very brief answer. 1.15. What is the ratio of the Emissions (1000 metric ton of CO2 equivalent) in Lithuania in 2005 to that in 2010?
Ensure brevity in your answer.  0.56. What is the ratio of the Emissions (1000 metric ton of CO2 equivalent) of Nicaragua in 2005 to that in 2010?
Your response must be concise. 1.03. What is the ratio of the Emissions (1000 metric ton of CO2 equivalent) in Trinidad and Tobago in 2005 to that in 2010?
Provide a short and direct response. 1.39. What is the ratio of the Emissions (1000 metric ton of CO2 equivalent) in Finland in 2008 to that in 2010?
Make the answer very short. 1.11. What is the ratio of the Emissions (1000 metric ton of CO2 equivalent) of Lithuania in 2008 to that in 2010?
Offer a terse response. 0.57. What is the ratio of the Emissions (1000 metric ton of CO2 equivalent) in Trinidad and Tobago in 2008 to that in 2010?
Give a very brief answer. 1.66. What is the difference between the highest and the second highest Emissions (1000 metric ton of CO2 equivalent) in Finland?
Your response must be concise. 648. What is the difference between the highest and the second highest Emissions (1000 metric ton of CO2 equivalent) in Lithuania?
Give a very brief answer. 75.9. What is the difference between the highest and the second highest Emissions (1000 metric ton of CO2 equivalent) in Nicaragua?
Provide a succinct answer. 69.2. What is the difference between the highest and the second highest Emissions (1000 metric ton of CO2 equivalent) of Trinidad and Tobago?
Your answer should be very brief. 27.5. What is the difference between the highest and the lowest Emissions (1000 metric ton of CO2 equivalent) of Finland?
Give a very brief answer. 1230.3. What is the difference between the highest and the lowest Emissions (1000 metric ton of CO2 equivalent) in Lithuania?
Provide a short and direct response. 1854.2. What is the difference between the highest and the lowest Emissions (1000 metric ton of CO2 equivalent) in Nicaragua?
Your answer should be compact. 211.4. What is the difference between the highest and the lowest Emissions (1000 metric ton of CO2 equivalent) of Trinidad and Tobago?
Offer a very short reply. 66.2. 